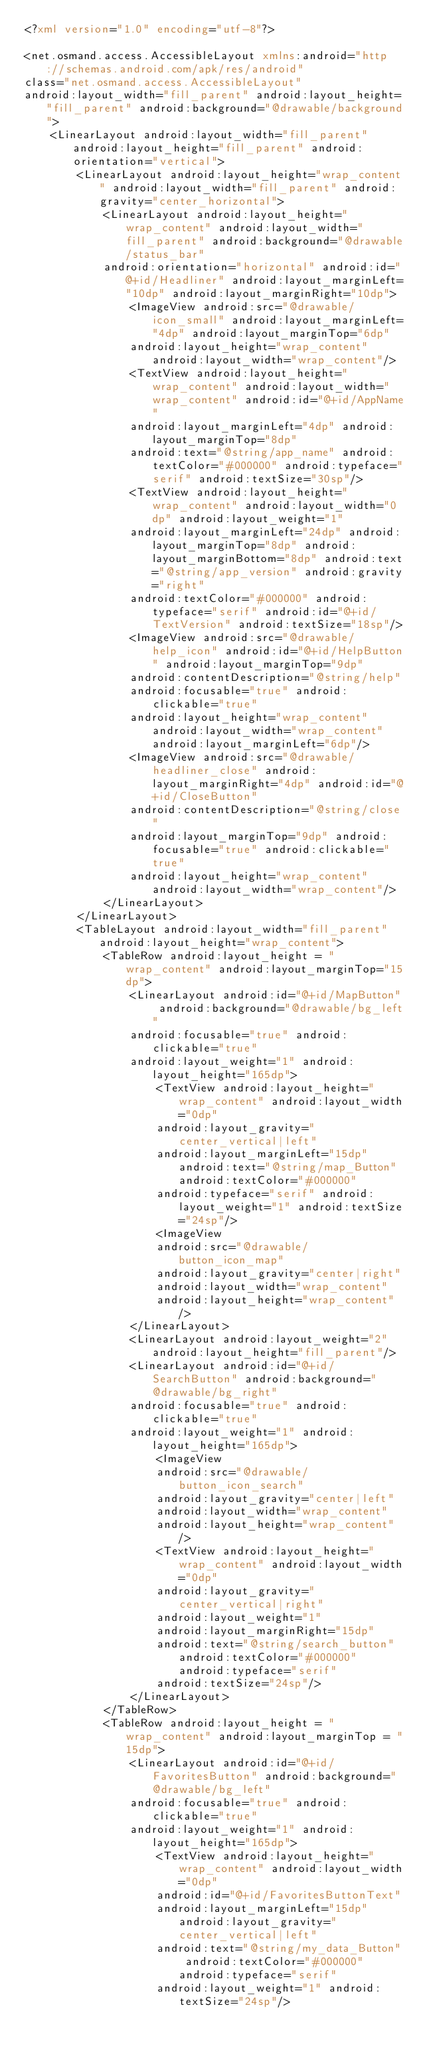Convert code to text. <code><loc_0><loc_0><loc_500><loc_500><_XML_><?xml version="1.0" encoding="utf-8"?>

<net.osmand.access.AccessibleLayout xmlns:android="http://schemas.android.com/apk/res/android"
class="net.osmand.access.AccessibleLayout"
android:layout_width="fill_parent" android:layout_height="fill_parent" android:background="@drawable/background">
	<LinearLayout android:layout_width="fill_parent" android:layout_height="fill_parent" android:orientation="vertical">
		<LinearLayout android:layout_height="wrap_content" android:layout_width="fill_parent" android:gravity="center_horizontal">
			<LinearLayout android:layout_height="wrap_content" android:layout_width="fill_parent" android:background="@drawable/status_bar" 
			android:orientation="horizontal" android:id="@+id/Headliner" android:layout_marginLeft="10dp" android:layout_marginRight="10dp">
				<ImageView android:src="@drawable/icon_small" android:layout_marginLeft="4dp" android:layout_marginTop="6dp"
				android:layout_height="wrap_content" android:layout_width="wrap_content"/>
				<TextView android:layout_height="wrap_content" android:layout_width="wrap_content" android:id="@+id/AppName" 
				android:layout_marginLeft="4dp" android:layout_marginTop="8dp" 
				android:text="@string/app_name" android:textColor="#000000" android:typeface="serif" android:textSize="30sp"/>
				<TextView android:layout_height="wrap_content" android:layout_width="0dp" android:layout_weight="1"
				android:layout_marginLeft="24dp" android:layout_marginTop="8dp" android:layout_marginBottom="8dp" android:text="@string/app_version" android:gravity="right"
				android:textColor="#000000" android:typeface="serif" android:id="@+id/TextVersion" android:textSize="18sp"/> 
				<ImageView android:src="@drawable/help_icon" android:id="@+id/HelpButton" android:layout_marginTop="9dp"
				android:contentDescription="@string/help"
				android:focusable="true" android:clickable="true"
				android:layout_height="wrap_content" android:layout_width="wrap_content" android:layout_marginLeft="6dp"/>
				<ImageView android:src="@drawable/headliner_close" android:layout_marginRight="4dp" android:id="@+id/CloseButton"
				android:contentDescription="@string/close"
				android:layout_marginTop="9dp" android:focusable="true" android:clickable="true"
				android:layout_height="wrap_content" android:layout_width="wrap_content"/>
			</LinearLayout>
		</LinearLayout>
		<TableLayout android:layout_width="fill_parent" android:layout_height="wrap_content">
	 		<TableRow android:layout_height = "wrap_content" android:layout_marginTop="15dp">
	 			<LinearLayout android:id="@+id/MapButton" android:background="@drawable/bg_left" 
	 			android:focusable="true" android:clickable="true"
	 			android:layout_weight="1" android:layout_height="165dp">
	 				<TextView android:layout_height="wrap_content" android:layout_width="0dp"
					android:layout_gravity="center_vertical|left" 
					android:layout_marginLeft="15dp" android:text="@string/map_Button" android:textColor="#000000"
					android:typeface="serif" android:layout_weight="1" android:textSize="24sp"/>
	 				<ImageView
					android:src="@drawable/button_icon_map"
					android:layout_gravity="center|right"
					android:layout_width="wrap_content"
					android:layout_height="wrap_content"/>
	 			</LinearLayout>
				<LinearLayout android:layout_weight="2" android:layout_height="fill_parent"/>
				<LinearLayout android:id="@+id/SearchButton" android:background="@drawable/bg_right" 
				android:focusable="true" android:clickable="true"
				android:layout_weight="1" android:layout_height="165dp">
					<ImageView
					android:src="@drawable/button_icon_search"
					android:layout_gravity="center|left"
					android:layout_width="wrap_content"
					android:layout_height="wrap_content"/>	
					<TextView android:layout_height="wrap_content" android:layout_width="0dp"
					android:layout_gravity="center_vertical|right"
					android:layout_weight="1"
					android:layout_marginRight="15dp"
					android:text="@string/search_button" android:textColor="#000000" android:typeface="serif"
					android:textSize="24sp"/>
				</LinearLayout>
			</TableRow>
			<TableRow android:layout_height = "wrap_content" android:layout_marginTop = "15dp">
				<LinearLayout android:id="@+id/FavoritesButton" android:background="@drawable/bg_left"
				android:focusable="true" android:clickable="true" 
				android:layout_weight="1" android:layout_height="165dp">
					<TextView android:layout_height="wrap_content" android:layout_width="0dp"
					android:id="@+id/FavoritesButtonText"
					android:layout_marginLeft="15dp" android:layout_gravity="center_vertical|left"
					android:text="@string/my_data_Button" android:textColor="#000000" android:typeface="serif"
					android:layout_weight="1" android:textSize="24sp"/></code> 